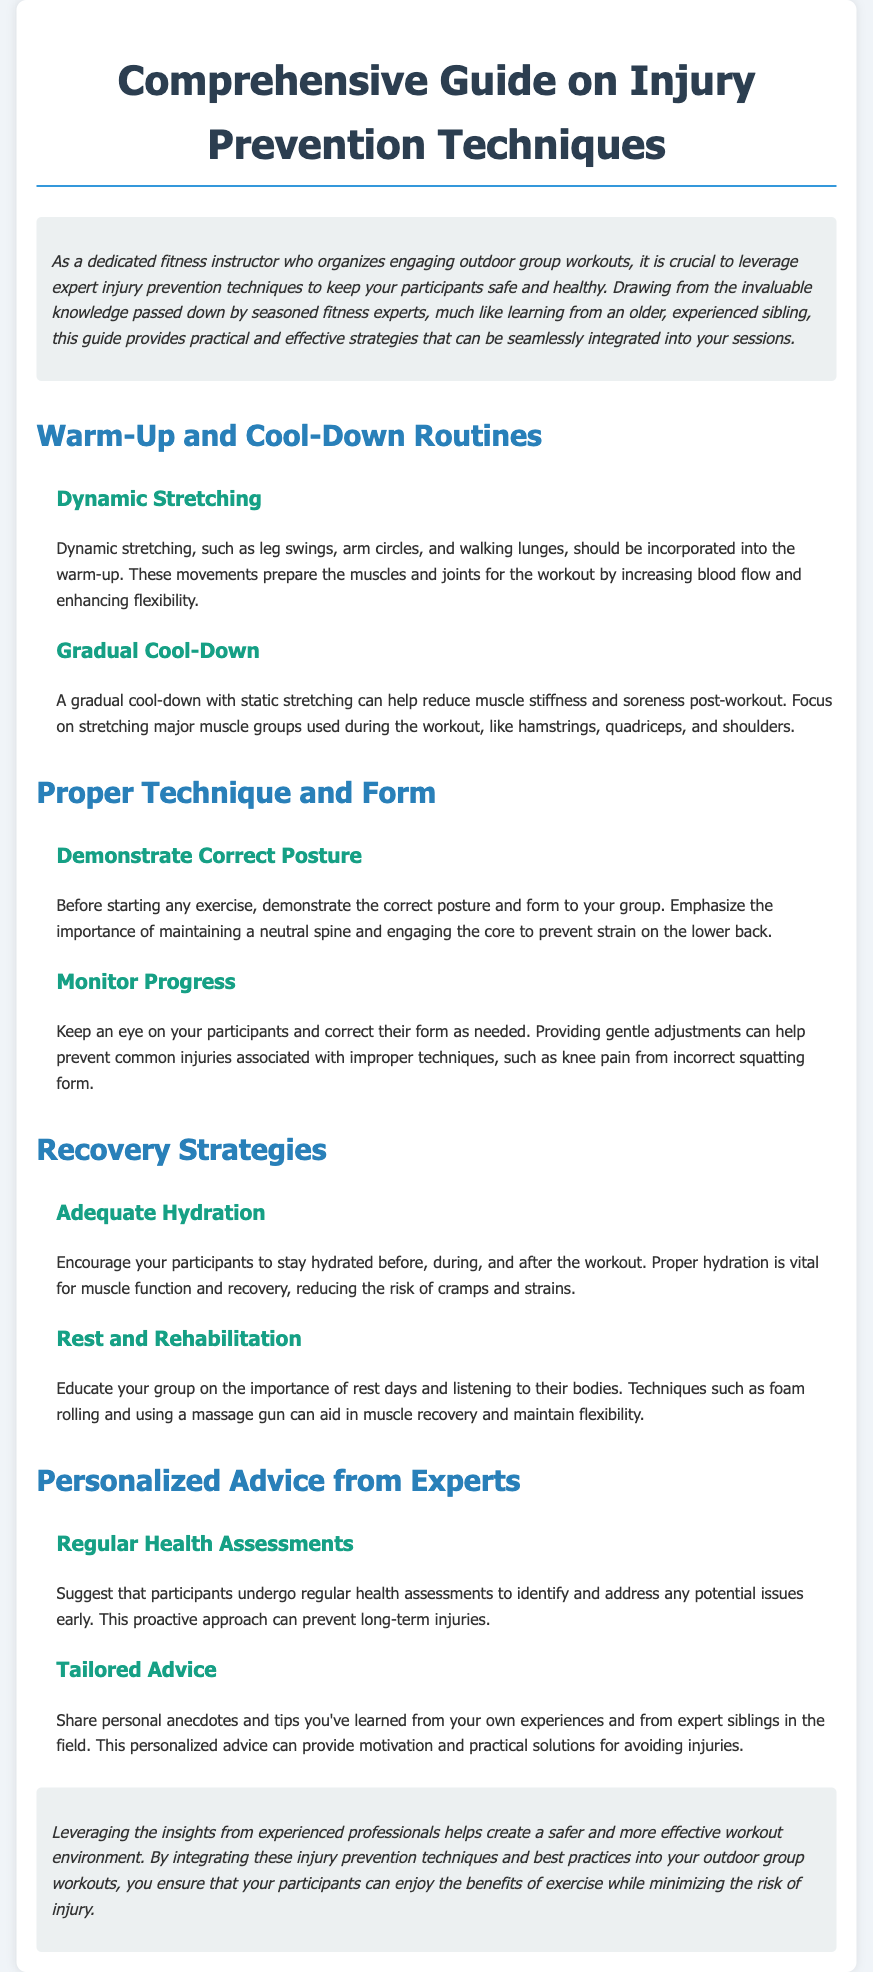What is the title of the guide? The title of the guide is stated at the top of the document, which is "Comprehensive Guide on Injury Prevention Techniques."
Answer: Comprehensive Guide on Injury Prevention Techniques What should be included in the warm-up? The section on warm-up discusses specific activities that prepare the muscles and joints, such as dynamic stretching.
Answer: Dynamic stretching What is the advice regarding hydration? The document emphasizes hydration's importance during different phases of a workout and its impact on muscle function.
Answer: Adequate Hydration What type of stretching is recommended for cooling down? The guide recommends a gradual cool-down with a specific kind of stretching to reduce muscle stiffness.
Answer: Static stretching What does the document suggest for monitoring participants? It mentions the importance of observing and correcting participants' techniques as part of injury prevention.
Answer: Monitor Progress What should participants do to prevent long-term injuries? The document advises undergoing regular assessments to catch potential issues early.
Answer: Regular Health Assessments What does the guide say about rest and recovery? It discusses the significance of resting and listening to the body's signals as crucial for recovery strategies.
Answer: Rest and Rehabilitation What is one way to aid in muscle recovery mentioned in the guide? The document suggests employing certain techniques that help in muscle recovery, such as foam rolling.
Answer: Foam rolling 